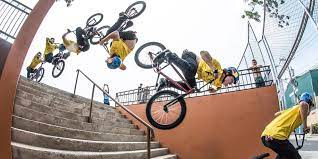Can you describe what's happening in the image? The image captures a sequence shot of a cyclist performing a jumping trick on a BMX bike down a flight of stairs, with the camera capturing multiple stages of the trick in one frame, showcasing the athlete's agility and skill. 